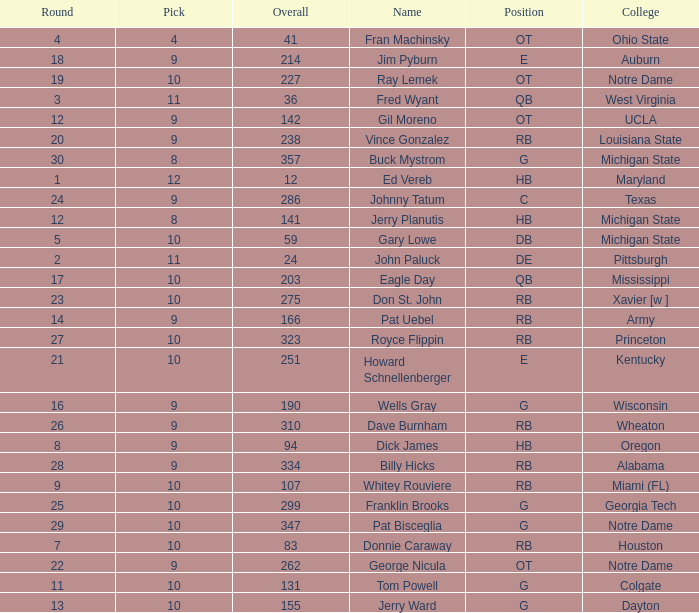What is the highest round number for donnie caraway? 7.0. 